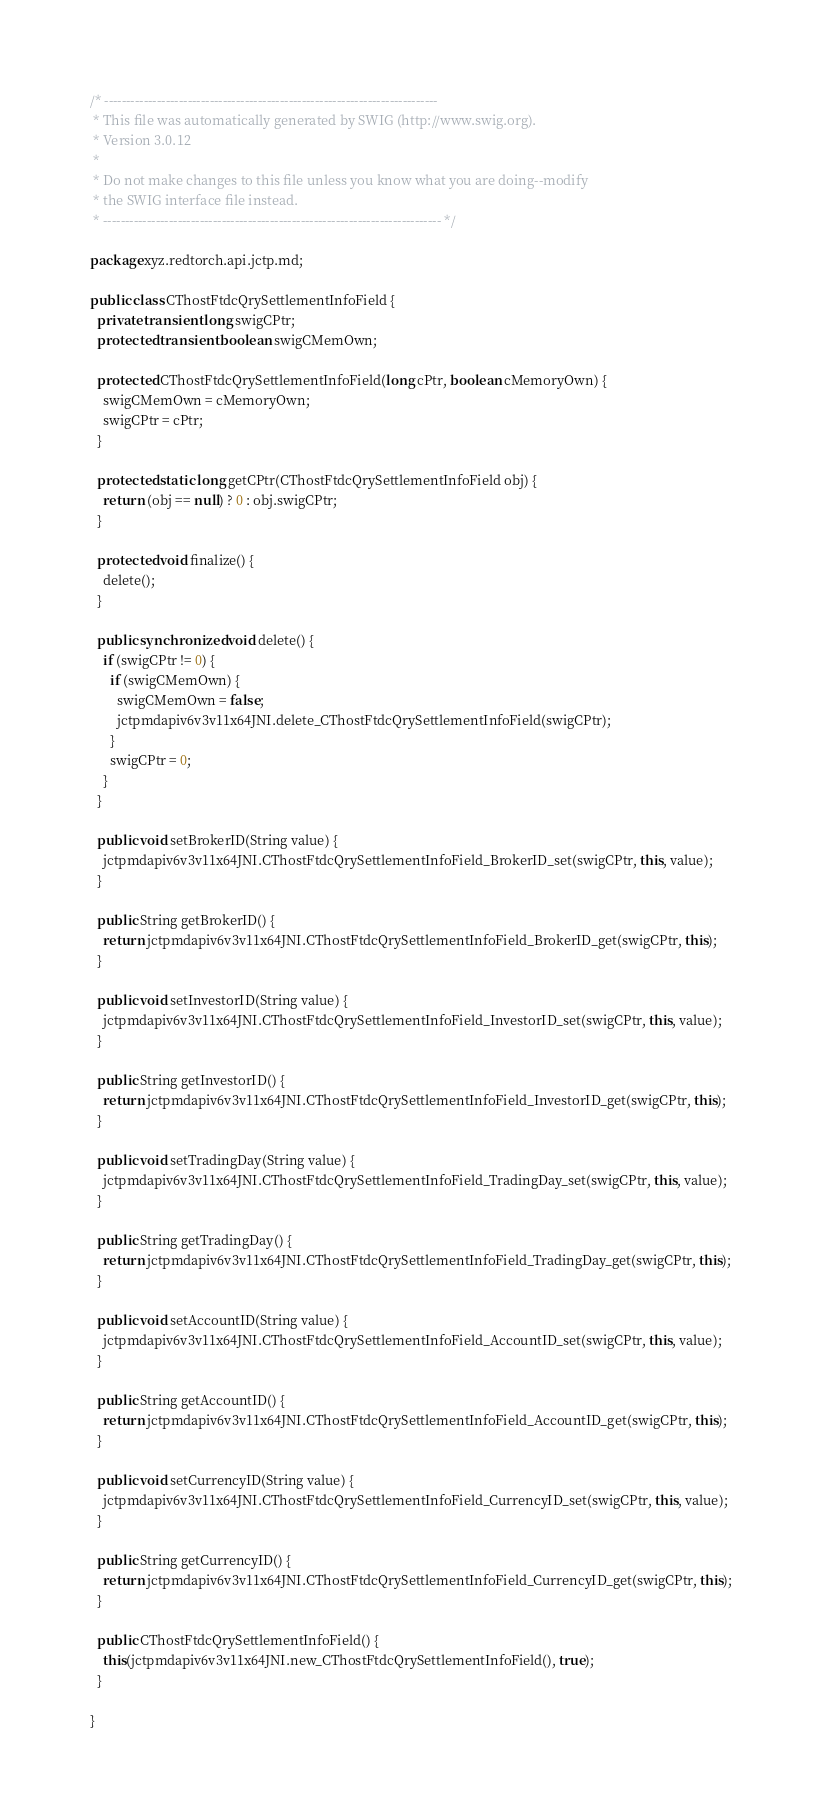<code> <loc_0><loc_0><loc_500><loc_500><_Java_>/* ----------------------------------------------------------------------------
 * This file was automatically generated by SWIG (http://www.swig.org).
 * Version 3.0.12
 *
 * Do not make changes to this file unless you know what you are doing--modify
 * the SWIG interface file instead.
 * ----------------------------------------------------------------------------- */

package xyz.redtorch.api.jctp.md;

public class CThostFtdcQrySettlementInfoField {
  private transient long swigCPtr;
  protected transient boolean swigCMemOwn;

  protected CThostFtdcQrySettlementInfoField(long cPtr, boolean cMemoryOwn) {
    swigCMemOwn = cMemoryOwn;
    swigCPtr = cPtr;
  }

  protected static long getCPtr(CThostFtdcQrySettlementInfoField obj) {
    return (obj == null) ? 0 : obj.swigCPtr;
  }

  protected void finalize() {
    delete();
  }

  public synchronized void delete() {
    if (swigCPtr != 0) {
      if (swigCMemOwn) {
        swigCMemOwn = false;
        jctpmdapiv6v3v11x64JNI.delete_CThostFtdcQrySettlementInfoField(swigCPtr);
      }
      swigCPtr = 0;
    }
  }

  public void setBrokerID(String value) {
    jctpmdapiv6v3v11x64JNI.CThostFtdcQrySettlementInfoField_BrokerID_set(swigCPtr, this, value);
  }

  public String getBrokerID() {
    return jctpmdapiv6v3v11x64JNI.CThostFtdcQrySettlementInfoField_BrokerID_get(swigCPtr, this);
  }

  public void setInvestorID(String value) {
    jctpmdapiv6v3v11x64JNI.CThostFtdcQrySettlementInfoField_InvestorID_set(swigCPtr, this, value);
  }

  public String getInvestorID() {
    return jctpmdapiv6v3v11x64JNI.CThostFtdcQrySettlementInfoField_InvestorID_get(swigCPtr, this);
  }

  public void setTradingDay(String value) {
    jctpmdapiv6v3v11x64JNI.CThostFtdcQrySettlementInfoField_TradingDay_set(swigCPtr, this, value);
  }

  public String getTradingDay() {
    return jctpmdapiv6v3v11x64JNI.CThostFtdcQrySettlementInfoField_TradingDay_get(swigCPtr, this);
  }

  public void setAccountID(String value) {
    jctpmdapiv6v3v11x64JNI.CThostFtdcQrySettlementInfoField_AccountID_set(swigCPtr, this, value);
  }

  public String getAccountID() {
    return jctpmdapiv6v3v11x64JNI.CThostFtdcQrySettlementInfoField_AccountID_get(swigCPtr, this);
  }

  public void setCurrencyID(String value) {
    jctpmdapiv6v3v11x64JNI.CThostFtdcQrySettlementInfoField_CurrencyID_set(swigCPtr, this, value);
  }

  public String getCurrencyID() {
    return jctpmdapiv6v3v11x64JNI.CThostFtdcQrySettlementInfoField_CurrencyID_get(swigCPtr, this);
  }

  public CThostFtdcQrySettlementInfoField() {
    this(jctpmdapiv6v3v11x64JNI.new_CThostFtdcQrySettlementInfoField(), true);
  }

}
</code> 